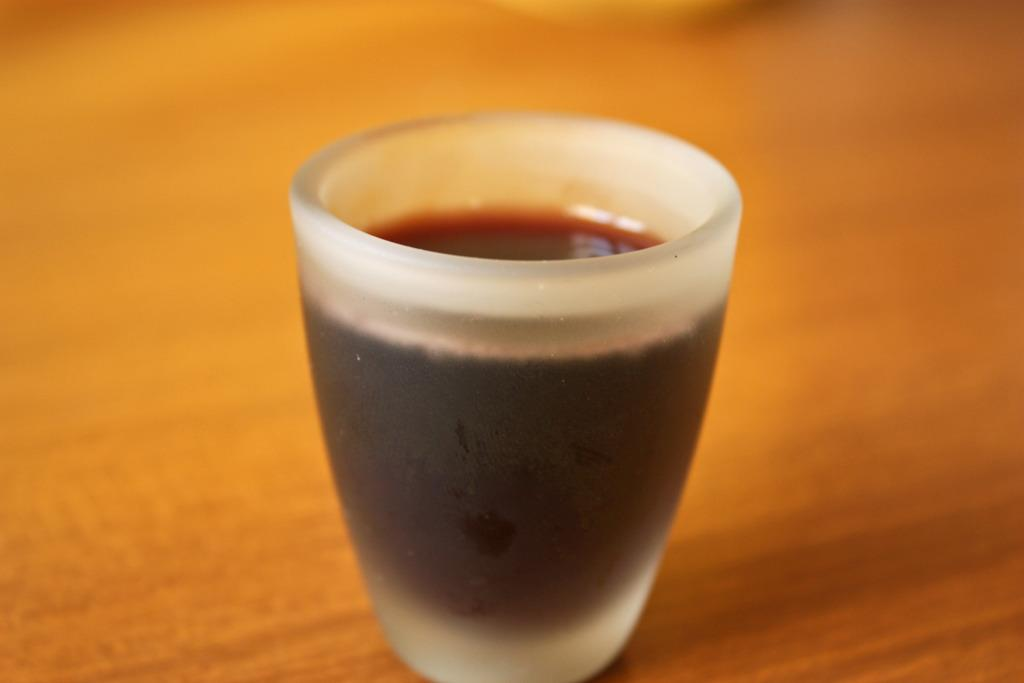What is located in the center of the image? There is a table in the center of the image. What object is placed on the table? There is a glass on the table. What is the color of the liquid in the glass? The water in the glass has a brown color. What is your opinion on the design of the desk in the image? There is no desk present in the image, only a table. What type of ink is used to write the word "ink" in the image? There is no word "ink" present in the image, and therefore no ink can be observed. 